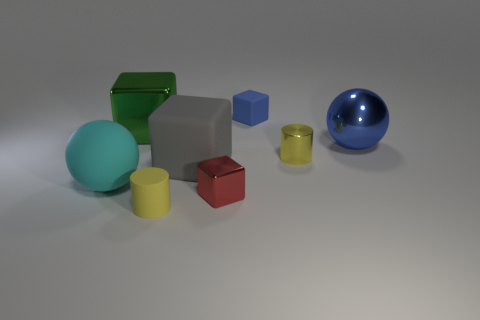There is a matte cube on the right side of the red metal object; does it have the same color as the large block behind the large blue metallic object?
Provide a succinct answer. No. Is the number of tiny yellow rubber cylinders that are behind the cyan ball greater than the number of objects that are in front of the green block?
Make the answer very short. No. What is the material of the gray thing?
Your response must be concise. Rubber. What is the shape of the tiny blue rubber thing that is on the right side of the large metal object on the left side of the tiny rubber thing that is behind the big metallic sphere?
Your answer should be very brief. Cube. How many other things are the same material as the blue sphere?
Keep it short and to the point. 3. Is the material of the small yellow cylinder that is behind the cyan sphere the same as the blue object behind the big blue metallic thing?
Provide a succinct answer. No. What number of tiny rubber objects are both left of the big gray block and to the right of the red shiny thing?
Provide a succinct answer. 0. Is there another green thing of the same shape as the large green metal object?
Provide a short and direct response. No. The red thing that is the same size as the shiny cylinder is what shape?
Make the answer very short. Cube. Are there an equal number of red objects behind the small blue object and big green blocks left of the large cyan ball?
Give a very brief answer. Yes. 